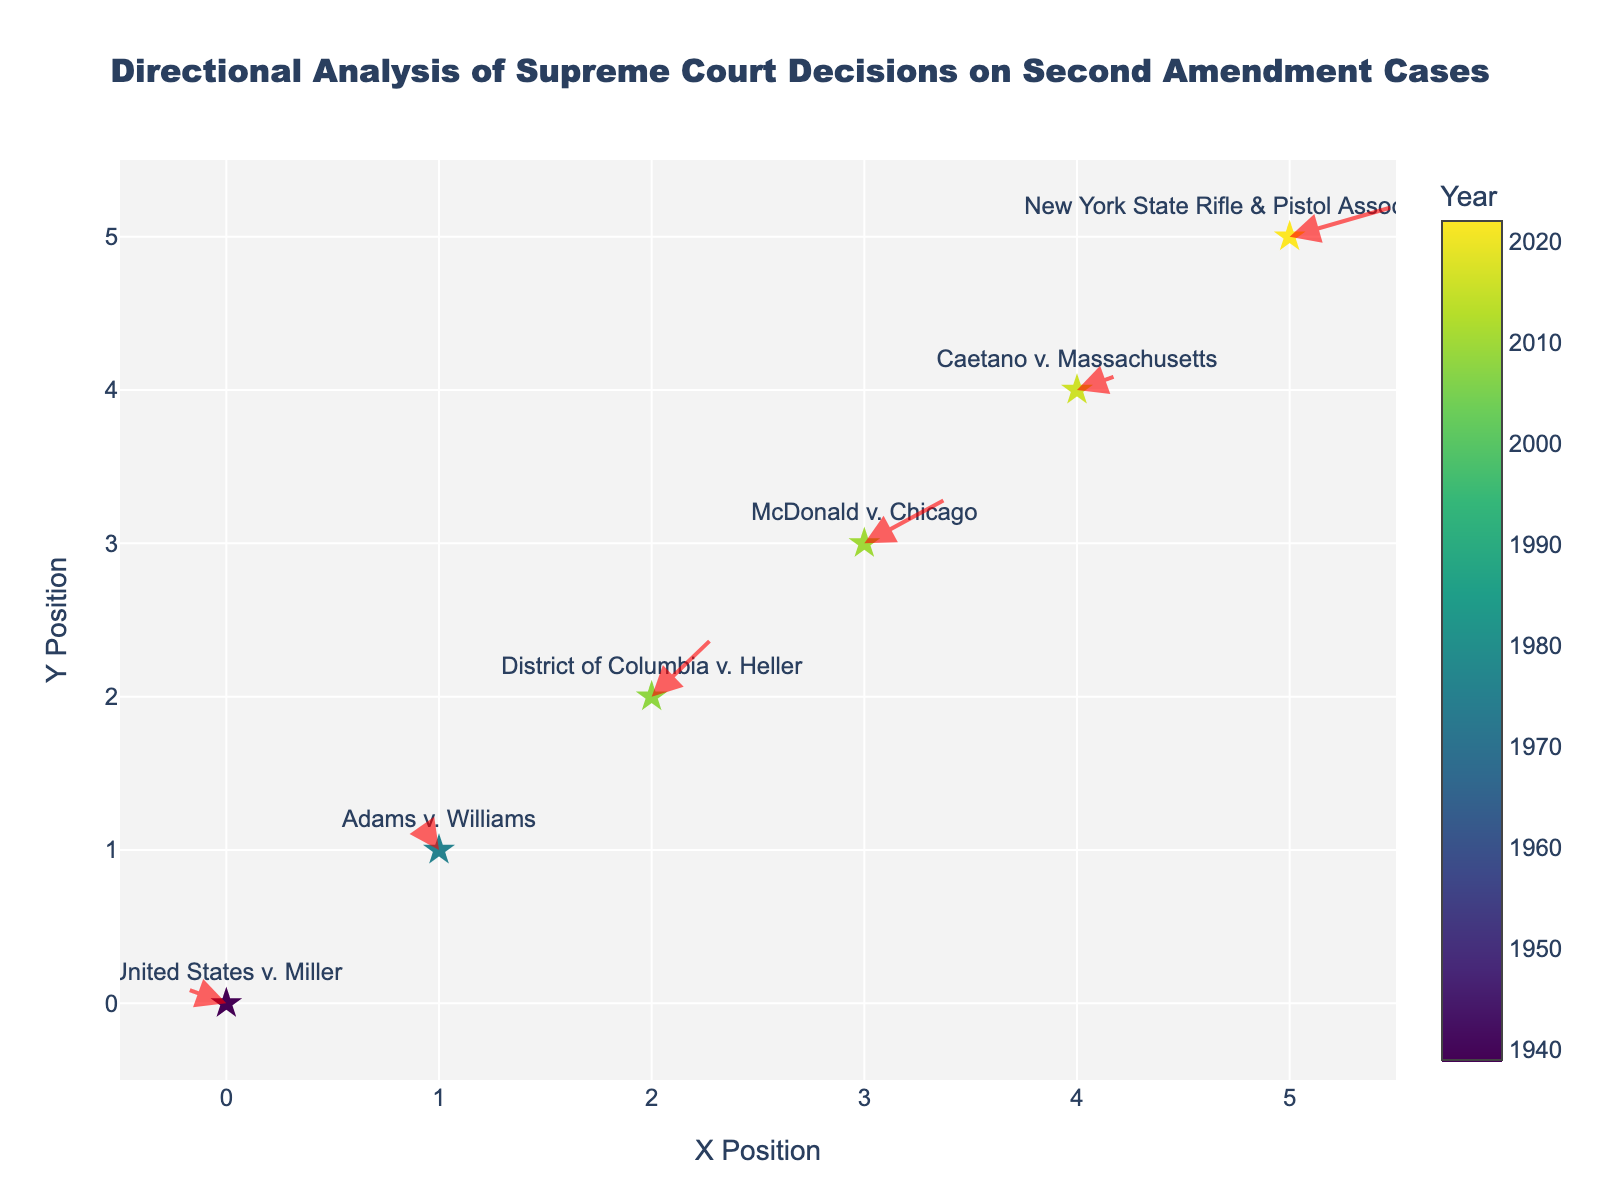What is the title of the plot? The title is displayed prominently at the top of the plot. It helps to understand the primary focus of the figure.
Answer: Directional Analysis of Supreme Court Decisions on Second Amendment Cases How many data points are in the plot? Each data point represents a Supreme Court case and is marked by a star symbol. Counting the stars gives the number of data points.
Answer: 6 Which cases have arrows pointing upwards? Arrows pointing upwards can be identified by their directional vectors showing a positive Y component (V > 0).
Answer: Adams v. Williams, District of Columbia v. Heller, McDonald v. Chicago Which year does the color represent New York State Rifle & Pistol Association v. Bruen? The color bar next to the figure indicates the years, and the star's color represents the year for each case. Find the color corresponding to New York State Rifle & Pistol Association v. Bruen.
Answer: 2022 What is the range of the X-axis? The X-axis range is shown at the bottom of the figure, indicating the minimum and maximum values covered by the axis.
Answer: -0.5 to 5.5 What is the overall directional trend of Court decisions from 1939 to 2022? Observing the arrows starting from 1939 (United States v. Miller) to 2022 (New York State Rifle & Pistol Association v. Bruen) reveals the overall movement path.
Answer: Predominantly towards the right and upwards Does District of Columbia v. Heller have a larger X or Y directional component (U or V)? By comparing the U and V values of District of Columbia v. Heller, we can determine which component is larger by direct comparison.
Answer: Y component (0.4) Compare the directional changes between McDonald v. Chicago and Caetano v. Massachusetts. Looking at the U and V values of both cases, analyze which one has a larger or smaller directional change based on these components.
Answer: McDonald v. Chicago has larger changes in both X (0.4) and Y (0.3) than Caetano v. Massachusetts (X: 0.2, Y: 0.1) Which case has the steepest arrow? The steepness of an arrow can be determined by the magnitude of its directional vectors U and V. The steeper the arrow, the larger the V component compared to the U component.
Answer: Adams v. Williams How does the direction of the arrow in United States v. Miller compare to the direction of the arrow in 2022 New York State Rifle & Pistol Association v. Bruen? By observing the directional vectors (U and V), compare the direction each arrow is pointing. United States v. Miller is pointing slightly upwards and to the left (negative U, positive V), whereas New York State Rifle & Pistol Association v. Bruen is pointing upwards and to the right (positive U, positive V).
Answer: Opposite directions 